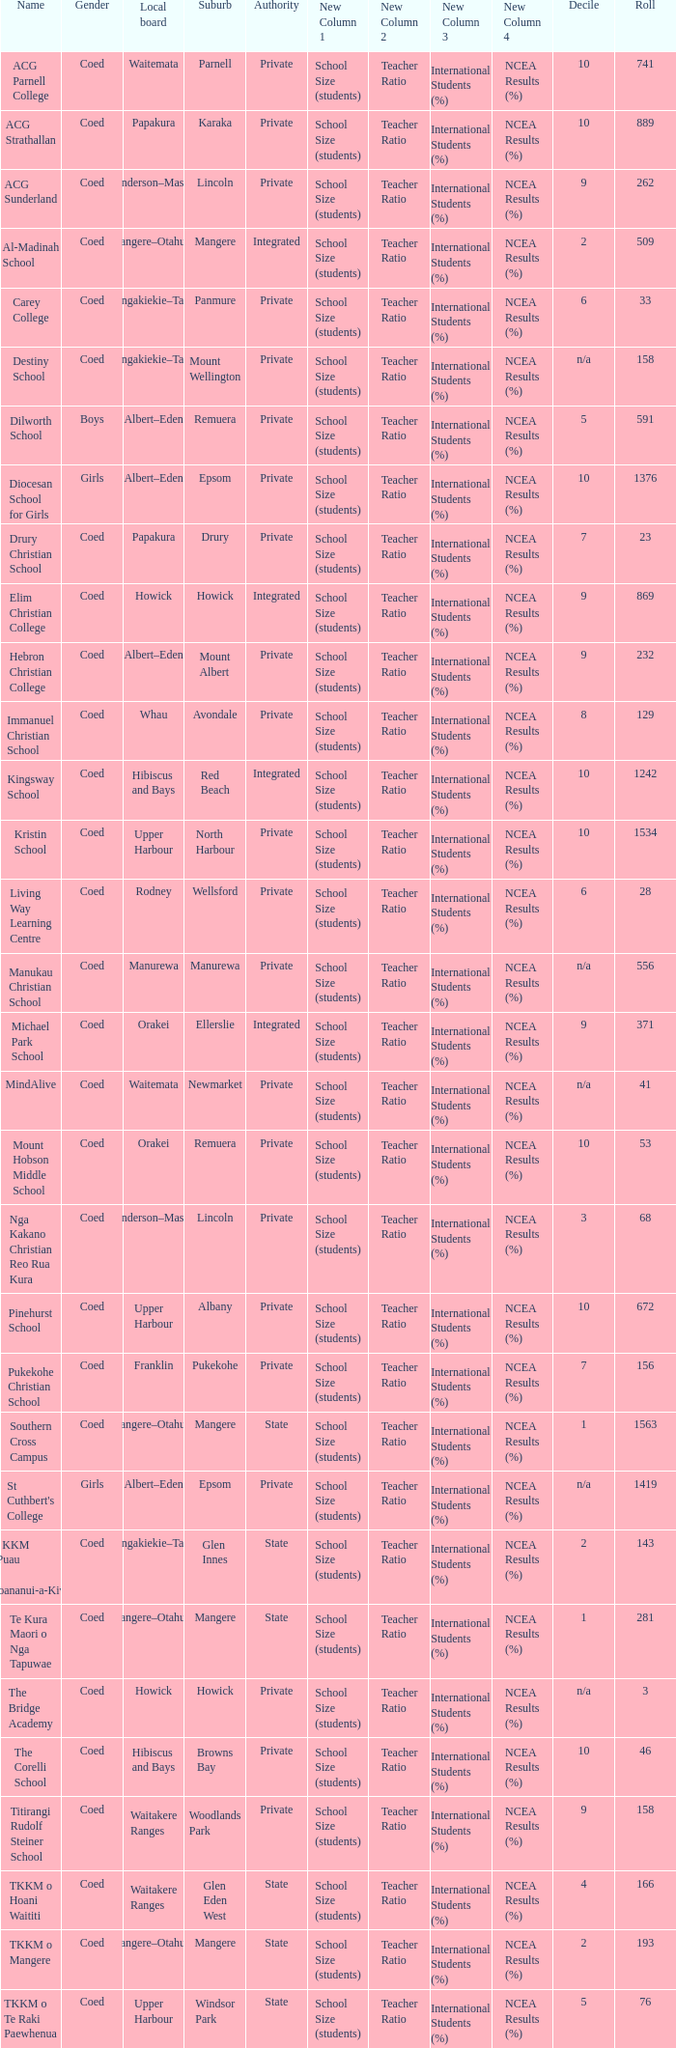What gender has a local board of albert–eden with a roll of more than 232 and Decile of 5? Boys. 